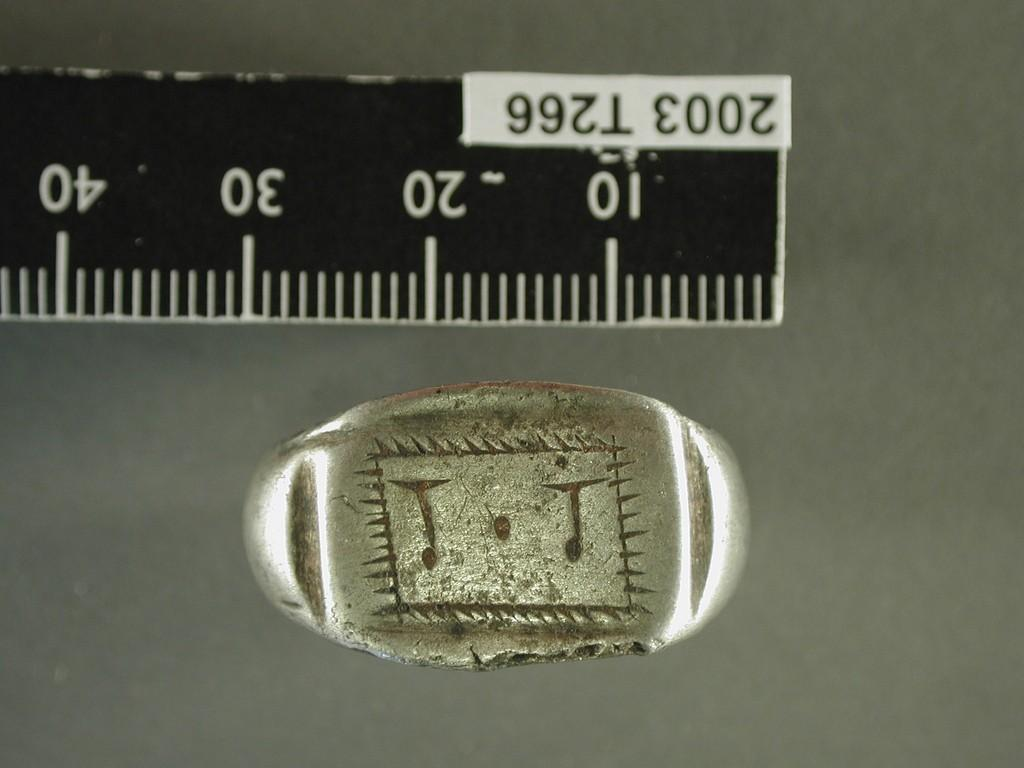What object is the main focus of the image? The main focus of the image is a scale. Where is the scale located in the image? The scale is on a platform. What type of button can be seen on the jeans in the image? There are no jeans or buttons present in the image; it only features a scale on a platform. 